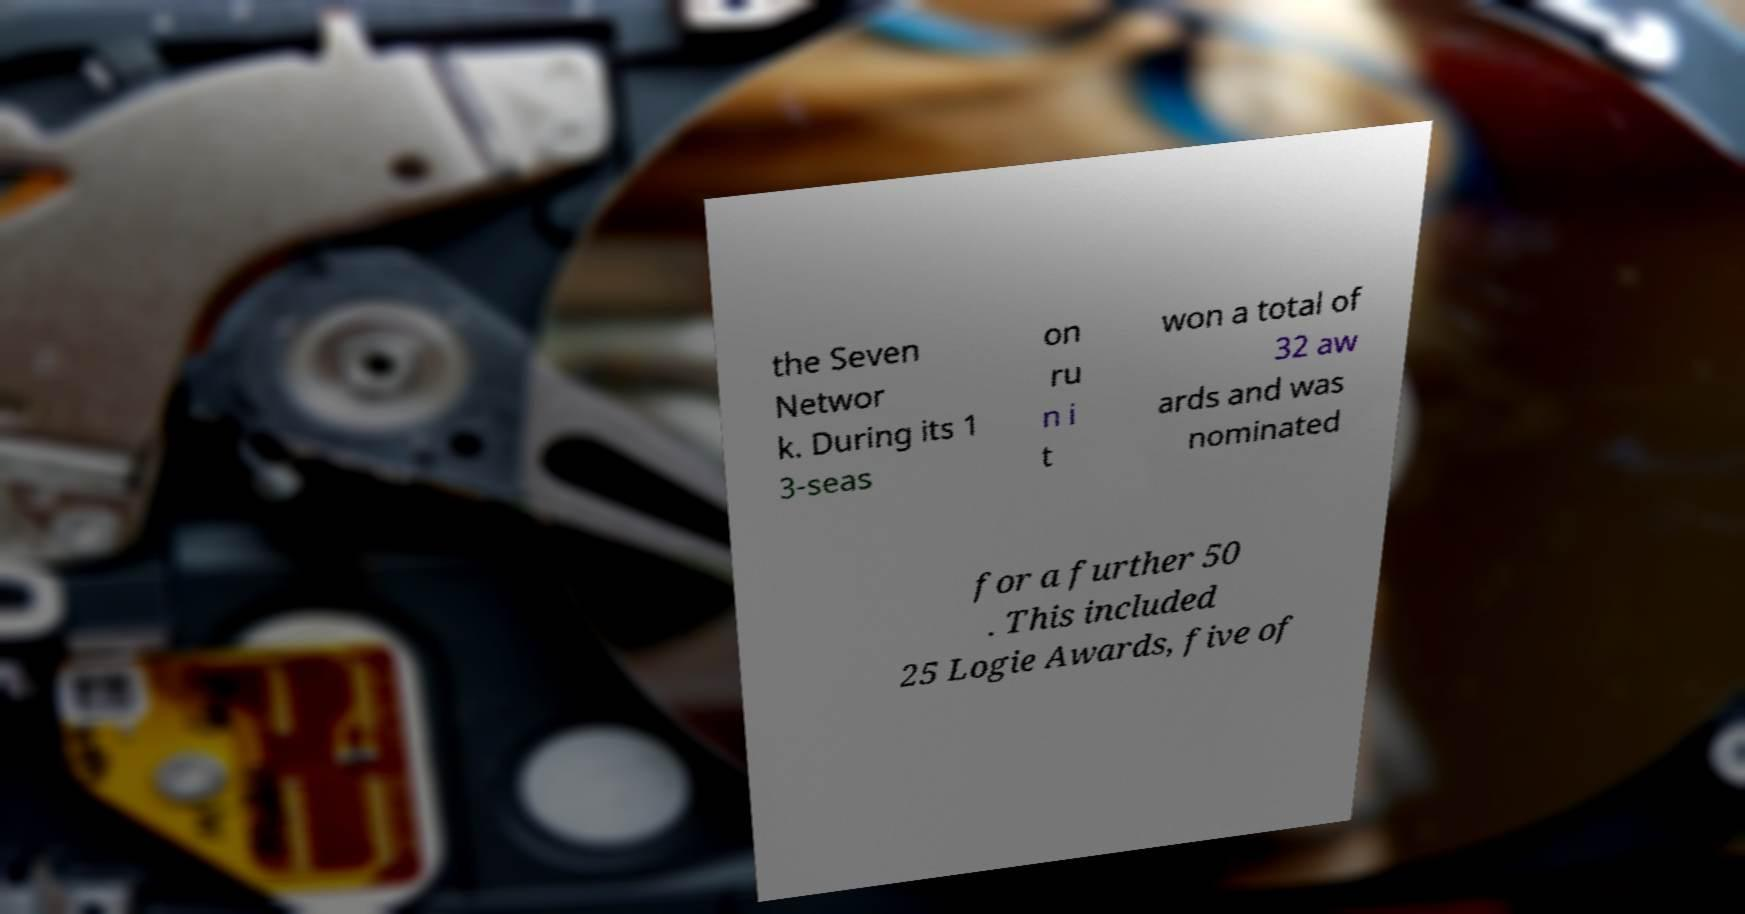What messages or text are displayed in this image? I need them in a readable, typed format. the Seven Networ k. During its 1 3-seas on ru n i t won a total of 32 aw ards and was nominated for a further 50 . This included 25 Logie Awards, five of 